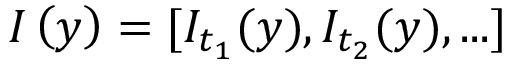<formula> <loc_0><loc_0><loc_500><loc_500>I \left ( y \right ) = [ I _ { t _ { 1 } } ( y ) , I _ { t _ { 2 } } ( y ) , \dots ]</formula> 